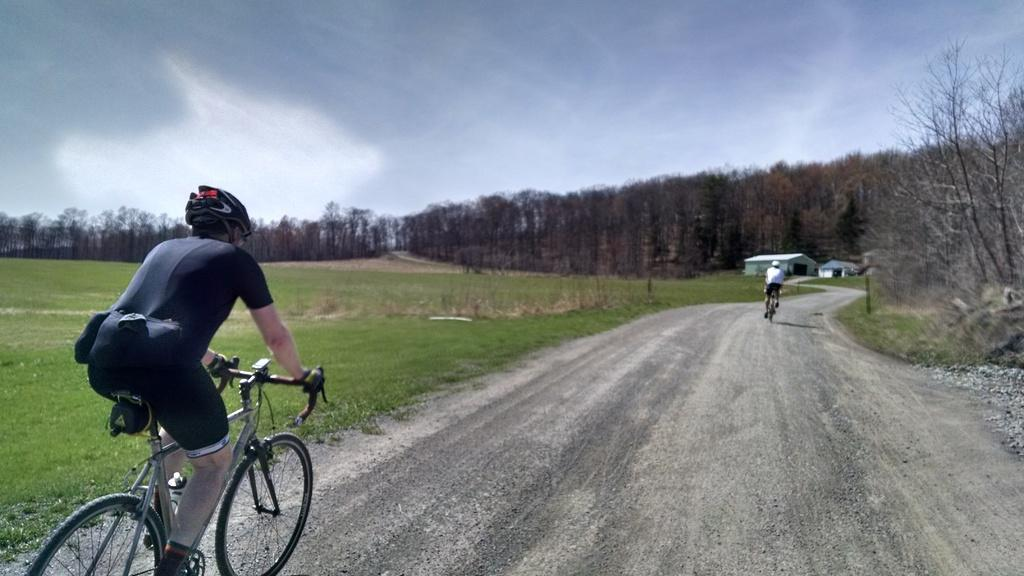How many people are in the image? There are two persons in the image. What are the persons doing in the image? Both persons are on cycles. Where are the persons located in the image? They are on a path. What can be seen beside the path in the image? There is grass beside the path. What is visible in the background of the image? There are trees and the sky in the background of the image. How many ants can be seen carrying the lead in the image? There are no ants or lead present in the image. What arithmetic problem is being solved by the persons on the cycles in the image? There is no arithmetic problem being solved in the image; the persons are simply riding their cycles on a path. 